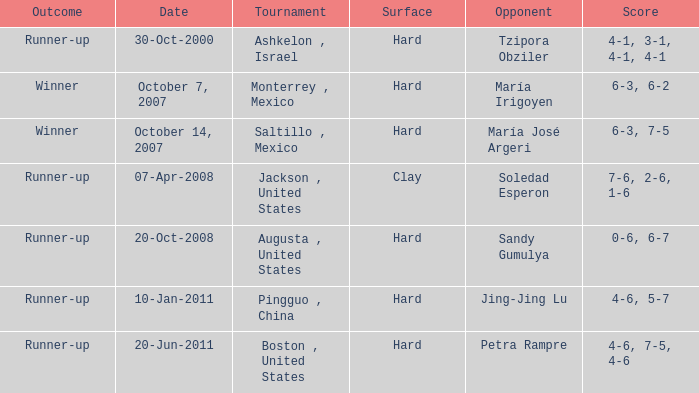Who was the opponent with a score of 4-6, 7-5, 4-6? Petra Rampre. 